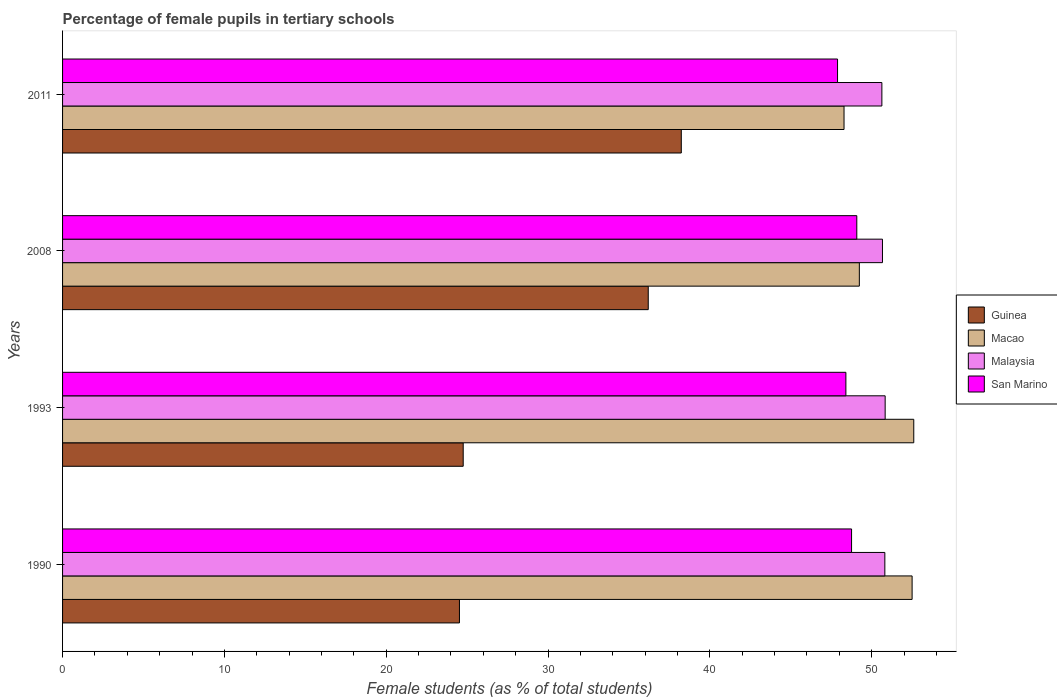Are the number of bars on each tick of the Y-axis equal?
Ensure brevity in your answer.  Yes. How many bars are there on the 2nd tick from the bottom?
Offer a terse response. 4. What is the percentage of female pupils in tertiary schools in Guinea in 1990?
Keep it short and to the point. 24.52. Across all years, what is the maximum percentage of female pupils in tertiary schools in Macao?
Provide a short and direct response. 52.6. Across all years, what is the minimum percentage of female pupils in tertiary schools in Guinea?
Provide a succinct answer. 24.52. In which year was the percentage of female pupils in tertiary schools in Macao maximum?
Provide a short and direct response. 1993. In which year was the percentage of female pupils in tertiary schools in San Marino minimum?
Provide a succinct answer. 2011. What is the total percentage of female pupils in tertiary schools in San Marino in the graph?
Make the answer very short. 194.12. What is the difference between the percentage of female pupils in tertiary schools in Macao in 2008 and that in 2011?
Make the answer very short. 0.95. What is the difference between the percentage of female pupils in tertiary schools in Malaysia in 1990 and the percentage of female pupils in tertiary schools in Guinea in 2008?
Ensure brevity in your answer.  14.62. What is the average percentage of female pupils in tertiary schools in Malaysia per year?
Ensure brevity in your answer.  50.73. In the year 1993, what is the difference between the percentage of female pupils in tertiary schools in Guinea and percentage of female pupils in tertiary schools in Malaysia?
Provide a succinct answer. -26.07. In how many years, is the percentage of female pupils in tertiary schools in Malaysia greater than 38 %?
Provide a short and direct response. 4. What is the ratio of the percentage of female pupils in tertiary schools in Guinea in 1990 to that in 2008?
Your response must be concise. 0.68. Is the difference between the percentage of female pupils in tertiary schools in Guinea in 1993 and 2008 greater than the difference between the percentage of female pupils in tertiary schools in Malaysia in 1993 and 2008?
Make the answer very short. No. What is the difference between the highest and the second highest percentage of female pupils in tertiary schools in San Marino?
Provide a short and direct response. 0.32. What is the difference between the highest and the lowest percentage of female pupils in tertiary schools in San Marino?
Your answer should be very brief. 1.19. In how many years, is the percentage of female pupils in tertiary schools in Guinea greater than the average percentage of female pupils in tertiary schools in Guinea taken over all years?
Ensure brevity in your answer.  2. Is it the case that in every year, the sum of the percentage of female pupils in tertiary schools in Malaysia and percentage of female pupils in tertiary schools in Macao is greater than the sum of percentage of female pupils in tertiary schools in San Marino and percentage of female pupils in tertiary schools in Guinea?
Provide a succinct answer. No. What does the 3rd bar from the top in 2011 represents?
Provide a short and direct response. Macao. What does the 2nd bar from the bottom in 2011 represents?
Keep it short and to the point. Macao. How many bars are there?
Provide a short and direct response. 16. Are the values on the major ticks of X-axis written in scientific E-notation?
Your answer should be very brief. No. Does the graph contain any zero values?
Ensure brevity in your answer.  No. Does the graph contain grids?
Your answer should be compact. No. Where does the legend appear in the graph?
Your answer should be compact. Center right. How are the legend labels stacked?
Ensure brevity in your answer.  Vertical. What is the title of the graph?
Keep it short and to the point. Percentage of female pupils in tertiary schools. Does "Canada" appear as one of the legend labels in the graph?
Keep it short and to the point. No. What is the label or title of the X-axis?
Provide a short and direct response. Female students (as % of total students). What is the label or title of the Y-axis?
Your response must be concise. Years. What is the Female students (as % of total students) of Guinea in 1990?
Your answer should be compact. 24.52. What is the Female students (as % of total students) of Macao in 1990?
Ensure brevity in your answer.  52.5. What is the Female students (as % of total students) of Malaysia in 1990?
Give a very brief answer. 50.81. What is the Female students (as % of total students) in San Marino in 1990?
Give a very brief answer. 48.75. What is the Female students (as % of total students) in Guinea in 1993?
Provide a short and direct response. 24.76. What is the Female students (as % of total students) of Macao in 1993?
Offer a terse response. 52.6. What is the Female students (as % of total students) of Malaysia in 1993?
Your response must be concise. 50.83. What is the Female students (as % of total students) of San Marino in 1993?
Make the answer very short. 48.4. What is the Female students (as % of total students) of Guinea in 2008?
Offer a very short reply. 36.19. What is the Female students (as % of total students) in Macao in 2008?
Keep it short and to the point. 49.24. What is the Female students (as % of total students) in Malaysia in 2008?
Your answer should be very brief. 50.66. What is the Female students (as % of total students) of San Marino in 2008?
Your answer should be very brief. 49.08. What is the Female students (as % of total students) in Guinea in 2011?
Make the answer very short. 38.23. What is the Female students (as % of total students) of Macao in 2011?
Give a very brief answer. 48.29. What is the Female students (as % of total students) in Malaysia in 2011?
Keep it short and to the point. 50.63. What is the Female students (as % of total students) of San Marino in 2011?
Your answer should be compact. 47.89. Across all years, what is the maximum Female students (as % of total students) in Guinea?
Offer a very short reply. 38.23. Across all years, what is the maximum Female students (as % of total students) of Macao?
Your answer should be compact. 52.6. Across all years, what is the maximum Female students (as % of total students) in Malaysia?
Make the answer very short. 50.83. Across all years, what is the maximum Female students (as % of total students) of San Marino?
Keep it short and to the point. 49.08. Across all years, what is the minimum Female students (as % of total students) in Guinea?
Offer a terse response. 24.52. Across all years, what is the minimum Female students (as % of total students) in Macao?
Your answer should be very brief. 48.29. Across all years, what is the minimum Female students (as % of total students) of Malaysia?
Make the answer very short. 50.63. Across all years, what is the minimum Female students (as % of total students) of San Marino?
Provide a short and direct response. 47.89. What is the total Female students (as % of total students) of Guinea in the graph?
Keep it short and to the point. 123.71. What is the total Female students (as % of total students) in Macao in the graph?
Your answer should be very brief. 202.62. What is the total Female students (as % of total students) in Malaysia in the graph?
Your answer should be very brief. 202.93. What is the total Female students (as % of total students) in San Marino in the graph?
Provide a succinct answer. 194.12. What is the difference between the Female students (as % of total students) in Guinea in 1990 and that in 1993?
Your answer should be very brief. -0.23. What is the difference between the Female students (as % of total students) of Macao in 1990 and that in 1993?
Ensure brevity in your answer.  -0.1. What is the difference between the Female students (as % of total students) of Malaysia in 1990 and that in 1993?
Make the answer very short. -0.02. What is the difference between the Female students (as % of total students) in San Marino in 1990 and that in 1993?
Your answer should be compact. 0.35. What is the difference between the Female students (as % of total students) in Guinea in 1990 and that in 2008?
Provide a short and direct response. -11.67. What is the difference between the Female students (as % of total students) of Macao in 1990 and that in 2008?
Your answer should be very brief. 3.26. What is the difference between the Female students (as % of total students) in Malaysia in 1990 and that in 2008?
Offer a terse response. 0.15. What is the difference between the Female students (as % of total students) of San Marino in 1990 and that in 2008?
Give a very brief answer. -0.32. What is the difference between the Female students (as % of total students) in Guinea in 1990 and that in 2011?
Keep it short and to the point. -13.71. What is the difference between the Female students (as % of total students) of Macao in 1990 and that in 2011?
Your response must be concise. 4.21. What is the difference between the Female students (as % of total students) of Malaysia in 1990 and that in 2011?
Your answer should be compact. 0.18. What is the difference between the Female students (as % of total students) in San Marino in 1990 and that in 2011?
Your answer should be compact. 0.87. What is the difference between the Female students (as % of total students) of Guinea in 1993 and that in 2008?
Make the answer very short. -11.43. What is the difference between the Female students (as % of total students) in Macao in 1993 and that in 2008?
Offer a terse response. 3.36. What is the difference between the Female students (as % of total students) in Malaysia in 1993 and that in 2008?
Provide a succinct answer. 0.17. What is the difference between the Female students (as % of total students) of San Marino in 1993 and that in 2008?
Your response must be concise. -0.67. What is the difference between the Female students (as % of total students) of Guinea in 1993 and that in 2011?
Make the answer very short. -13.48. What is the difference between the Female students (as % of total students) of Macao in 1993 and that in 2011?
Provide a short and direct response. 4.31. What is the difference between the Female students (as % of total students) of Malaysia in 1993 and that in 2011?
Provide a short and direct response. 0.2. What is the difference between the Female students (as % of total students) of San Marino in 1993 and that in 2011?
Your answer should be compact. 0.52. What is the difference between the Female students (as % of total students) of Guinea in 2008 and that in 2011?
Your answer should be compact. -2.04. What is the difference between the Female students (as % of total students) of Macao in 2008 and that in 2011?
Give a very brief answer. 0.95. What is the difference between the Female students (as % of total students) of Malaysia in 2008 and that in 2011?
Offer a terse response. 0.04. What is the difference between the Female students (as % of total students) in San Marino in 2008 and that in 2011?
Keep it short and to the point. 1.19. What is the difference between the Female students (as % of total students) in Guinea in 1990 and the Female students (as % of total students) in Macao in 1993?
Ensure brevity in your answer.  -28.07. What is the difference between the Female students (as % of total students) in Guinea in 1990 and the Female students (as % of total students) in Malaysia in 1993?
Provide a succinct answer. -26.31. What is the difference between the Female students (as % of total students) of Guinea in 1990 and the Female students (as % of total students) of San Marino in 1993?
Keep it short and to the point. -23.88. What is the difference between the Female students (as % of total students) in Macao in 1990 and the Female students (as % of total students) in Malaysia in 1993?
Your answer should be compact. 1.67. What is the difference between the Female students (as % of total students) in Macao in 1990 and the Female students (as % of total students) in San Marino in 1993?
Provide a succinct answer. 4.09. What is the difference between the Female students (as % of total students) in Malaysia in 1990 and the Female students (as % of total students) in San Marino in 1993?
Ensure brevity in your answer.  2.41. What is the difference between the Female students (as % of total students) in Guinea in 1990 and the Female students (as % of total students) in Macao in 2008?
Offer a very short reply. -24.71. What is the difference between the Female students (as % of total students) of Guinea in 1990 and the Female students (as % of total students) of Malaysia in 2008?
Provide a succinct answer. -26.14. What is the difference between the Female students (as % of total students) of Guinea in 1990 and the Female students (as % of total students) of San Marino in 2008?
Your answer should be very brief. -24.55. What is the difference between the Female students (as % of total students) in Macao in 1990 and the Female students (as % of total students) in Malaysia in 2008?
Offer a very short reply. 1.83. What is the difference between the Female students (as % of total students) in Macao in 1990 and the Female students (as % of total students) in San Marino in 2008?
Give a very brief answer. 3.42. What is the difference between the Female students (as % of total students) in Malaysia in 1990 and the Female students (as % of total students) in San Marino in 2008?
Offer a very short reply. 1.73. What is the difference between the Female students (as % of total students) in Guinea in 1990 and the Female students (as % of total students) in Macao in 2011?
Provide a short and direct response. -23.76. What is the difference between the Female students (as % of total students) of Guinea in 1990 and the Female students (as % of total students) of Malaysia in 2011?
Provide a short and direct response. -26.1. What is the difference between the Female students (as % of total students) of Guinea in 1990 and the Female students (as % of total students) of San Marino in 2011?
Make the answer very short. -23.36. What is the difference between the Female students (as % of total students) of Macao in 1990 and the Female students (as % of total students) of Malaysia in 2011?
Offer a very short reply. 1.87. What is the difference between the Female students (as % of total students) in Macao in 1990 and the Female students (as % of total students) in San Marino in 2011?
Keep it short and to the point. 4.61. What is the difference between the Female students (as % of total students) in Malaysia in 1990 and the Female students (as % of total students) in San Marino in 2011?
Provide a succinct answer. 2.92. What is the difference between the Female students (as % of total students) of Guinea in 1993 and the Female students (as % of total students) of Macao in 2008?
Provide a short and direct response. -24.48. What is the difference between the Female students (as % of total students) of Guinea in 1993 and the Female students (as % of total students) of Malaysia in 2008?
Your answer should be compact. -25.91. What is the difference between the Female students (as % of total students) of Guinea in 1993 and the Female students (as % of total students) of San Marino in 2008?
Keep it short and to the point. -24.32. What is the difference between the Female students (as % of total students) in Macao in 1993 and the Female students (as % of total students) in Malaysia in 2008?
Your answer should be very brief. 1.93. What is the difference between the Female students (as % of total students) in Macao in 1993 and the Female students (as % of total students) in San Marino in 2008?
Your answer should be very brief. 3.52. What is the difference between the Female students (as % of total students) of Malaysia in 1993 and the Female students (as % of total students) of San Marino in 2008?
Ensure brevity in your answer.  1.75. What is the difference between the Female students (as % of total students) of Guinea in 1993 and the Female students (as % of total students) of Macao in 2011?
Ensure brevity in your answer.  -23.53. What is the difference between the Female students (as % of total students) in Guinea in 1993 and the Female students (as % of total students) in Malaysia in 2011?
Keep it short and to the point. -25.87. What is the difference between the Female students (as % of total students) in Guinea in 1993 and the Female students (as % of total students) in San Marino in 2011?
Make the answer very short. -23.13. What is the difference between the Female students (as % of total students) in Macao in 1993 and the Female students (as % of total students) in Malaysia in 2011?
Provide a succinct answer. 1.97. What is the difference between the Female students (as % of total students) in Macao in 1993 and the Female students (as % of total students) in San Marino in 2011?
Provide a succinct answer. 4.71. What is the difference between the Female students (as % of total students) of Malaysia in 1993 and the Female students (as % of total students) of San Marino in 2011?
Keep it short and to the point. 2.94. What is the difference between the Female students (as % of total students) of Guinea in 2008 and the Female students (as % of total students) of Macao in 2011?
Offer a very short reply. -12.1. What is the difference between the Female students (as % of total students) in Guinea in 2008 and the Female students (as % of total students) in Malaysia in 2011?
Ensure brevity in your answer.  -14.44. What is the difference between the Female students (as % of total students) in Guinea in 2008 and the Female students (as % of total students) in San Marino in 2011?
Offer a terse response. -11.7. What is the difference between the Female students (as % of total students) in Macao in 2008 and the Female students (as % of total students) in Malaysia in 2011?
Offer a very short reply. -1.39. What is the difference between the Female students (as % of total students) of Macao in 2008 and the Female students (as % of total students) of San Marino in 2011?
Offer a very short reply. 1.35. What is the difference between the Female students (as % of total students) in Malaysia in 2008 and the Female students (as % of total students) in San Marino in 2011?
Your answer should be very brief. 2.78. What is the average Female students (as % of total students) of Guinea per year?
Your response must be concise. 30.93. What is the average Female students (as % of total students) in Macao per year?
Make the answer very short. 50.65. What is the average Female students (as % of total students) in Malaysia per year?
Give a very brief answer. 50.73. What is the average Female students (as % of total students) in San Marino per year?
Offer a terse response. 48.53. In the year 1990, what is the difference between the Female students (as % of total students) of Guinea and Female students (as % of total students) of Macao?
Your answer should be compact. -27.97. In the year 1990, what is the difference between the Female students (as % of total students) in Guinea and Female students (as % of total students) in Malaysia?
Offer a terse response. -26.29. In the year 1990, what is the difference between the Female students (as % of total students) in Guinea and Female students (as % of total students) in San Marino?
Keep it short and to the point. -24.23. In the year 1990, what is the difference between the Female students (as % of total students) in Macao and Female students (as % of total students) in Malaysia?
Offer a very short reply. 1.69. In the year 1990, what is the difference between the Female students (as % of total students) in Macao and Female students (as % of total students) in San Marino?
Make the answer very short. 3.74. In the year 1990, what is the difference between the Female students (as % of total students) of Malaysia and Female students (as % of total students) of San Marino?
Provide a short and direct response. 2.06. In the year 1993, what is the difference between the Female students (as % of total students) in Guinea and Female students (as % of total students) in Macao?
Offer a terse response. -27.84. In the year 1993, what is the difference between the Female students (as % of total students) of Guinea and Female students (as % of total students) of Malaysia?
Keep it short and to the point. -26.07. In the year 1993, what is the difference between the Female students (as % of total students) in Guinea and Female students (as % of total students) in San Marino?
Ensure brevity in your answer.  -23.65. In the year 1993, what is the difference between the Female students (as % of total students) in Macao and Female students (as % of total students) in Malaysia?
Your answer should be very brief. 1.77. In the year 1993, what is the difference between the Female students (as % of total students) of Macao and Female students (as % of total students) of San Marino?
Offer a very short reply. 4.19. In the year 1993, what is the difference between the Female students (as % of total students) in Malaysia and Female students (as % of total students) in San Marino?
Provide a short and direct response. 2.43. In the year 2008, what is the difference between the Female students (as % of total students) in Guinea and Female students (as % of total students) in Macao?
Your response must be concise. -13.04. In the year 2008, what is the difference between the Female students (as % of total students) of Guinea and Female students (as % of total students) of Malaysia?
Ensure brevity in your answer.  -14.47. In the year 2008, what is the difference between the Female students (as % of total students) in Guinea and Female students (as % of total students) in San Marino?
Make the answer very short. -12.89. In the year 2008, what is the difference between the Female students (as % of total students) of Macao and Female students (as % of total students) of Malaysia?
Your response must be concise. -1.43. In the year 2008, what is the difference between the Female students (as % of total students) of Macao and Female students (as % of total students) of San Marino?
Provide a short and direct response. 0.16. In the year 2008, what is the difference between the Female students (as % of total students) of Malaysia and Female students (as % of total students) of San Marino?
Your answer should be compact. 1.59. In the year 2011, what is the difference between the Female students (as % of total students) in Guinea and Female students (as % of total students) in Macao?
Give a very brief answer. -10.06. In the year 2011, what is the difference between the Female students (as % of total students) in Guinea and Female students (as % of total students) in Malaysia?
Give a very brief answer. -12.39. In the year 2011, what is the difference between the Female students (as % of total students) in Guinea and Female students (as % of total students) in San Marino?
Your answer should be compact. -9.66. In the year 2011, what is the difference between the Female students (as % of total students) of Macao and Female students (as % of total students) of Malaysia?
Provide a succinct answer. -2.34. In the year 2011, what is the difference between the Female students (as % of total students) in Macao and Female students (as % of total students) in San Marino?
Keep it short and to the point. 0.4. In the year 2011, what is the difference between the Female students (as % of total students) of Malaysia and Female students (as % of total students) of San Marino?
Offer a very short reply. 2.74. What is the ratio of the Female students (as % of total students) of Guinea in 1990 to that in 1993?
Offer a terse response. 0.99. What is the ratio of the Female students (as % of total students) of Macao in 1990 to that in 1993?
Your response must be concise. 1. What is the ratio of the Female students (as % of total students) of Malaysia in 1990 to that in 1993?
Offer a terse response. 1. What is the ratio of the Female students (as % of total students) in Guinea in 1990 to that in 2008?
Your answer should be very brief. 0.68. What is the ratio of the Female students (as % of total students) in Macao in 1990 to that in 2008?
Offer a very short reply. 1.07. What is the ratio of the Female students (as % of total students) in Malaysia in 1990 to that in 2008?
Make the answer very short. 1. What is the ratio of the Female students (as % of total students) in San Marino in 1990 to that in 2008?
Make the answer very short. 0.99. What is the ratio of the Female students (as % of total students) of Guinea in 1990 to that in 2011?
Your response must be concise. 0.64. What is the ratio of the Female students (as % of total students) of Macao in 1990 to that in 2011?
Keep it short and to the point. 1.09. What is the ratio of the Female students (as % of total students) of Malaysia in 1990 to that in 2011?
Your answer should be compact. 1. What is the ratio of the Female students (as % of total students) of San Marino in 1990 to that in 2011?
Your answer should be compact. 1.02. What is the ratio of the Female students (as % of total students) in Guinea in 1993 to that in 2008?
Ensure brevity in your answer.  0.68. What is the ratio of the Female students (as % of total students) of Macao in 1993 to that in 2008?
Your response must be concise. 1.07. What is the ratio of the Female students (as % of total students) in Malaysia in 1993 to that in 2008?
Your response must be concise. 1. What is the ratio of the Female students (as % of total students) of San Marino in 1993 to that in 2008?
Your answer should be very brief. 0.99. What is the ratio of the Female students (as % of total students) of Guinea in 1993 to that in 2011?
Offer a very short reply. 0.65. What is the ratio of the Female students (as % of total students) of Macao in 1993 to that in 2011?
Your response must be concise. 1.09. What is the ratio of the Female students (as % of total students) in Malaysia in 1993 to that in 2011?
Your response must be concise. 1. What is the ratio of the Female students (as % of total students) in San Marino in 1993 to that in 2011?
Provide a succinct answer. 1.01. What is the ratio of the Female students (as % of total students) of Guinea in 2008 to that in 2011?
Provide a succinct answer. 0.95. What is the ratio of the Female students (as % of total students) of Macao in 2008 to that in 2011?
Your answer should be very brief. 1.02. What is the ratio of the Female students (as % of total students) in San Marino in 2008 to that in 2011?
Your answer should be very brief. 1.02. What is the difference between the highest and the second highest Female students (as % of total students) in Guinea?
Give a very brief answer. 2.04. What is the difference between the highest and the second highest Female students (as % of total students) in Macao?
Offer a terse response. 0.1. What is the difference between the highest and the second highest Female students (as % of total students) in Malaysia?
Give a very brief answer. 0.02. What is the difference between the highest and the second highest Female students (as % of total students) in San Marino?
Offer a terse response. 0.32. What is the difference between the highest and the lowest Female students (as % of total students) of Guinea?
Make the answer very short. 13.71. What is the difference between the highest and the lowest Female students (as % of total students) in Macao?
Provide a short and direct response. 4.31. What is the difference between the highest and the lowest Female students (as % of total students) of Malaysia?
Your answer should be compact. 0.2. What is the difference between the highest and the lowest Female students (as % of total students) in San Marino?
Your answer should be compact. 1.19. 